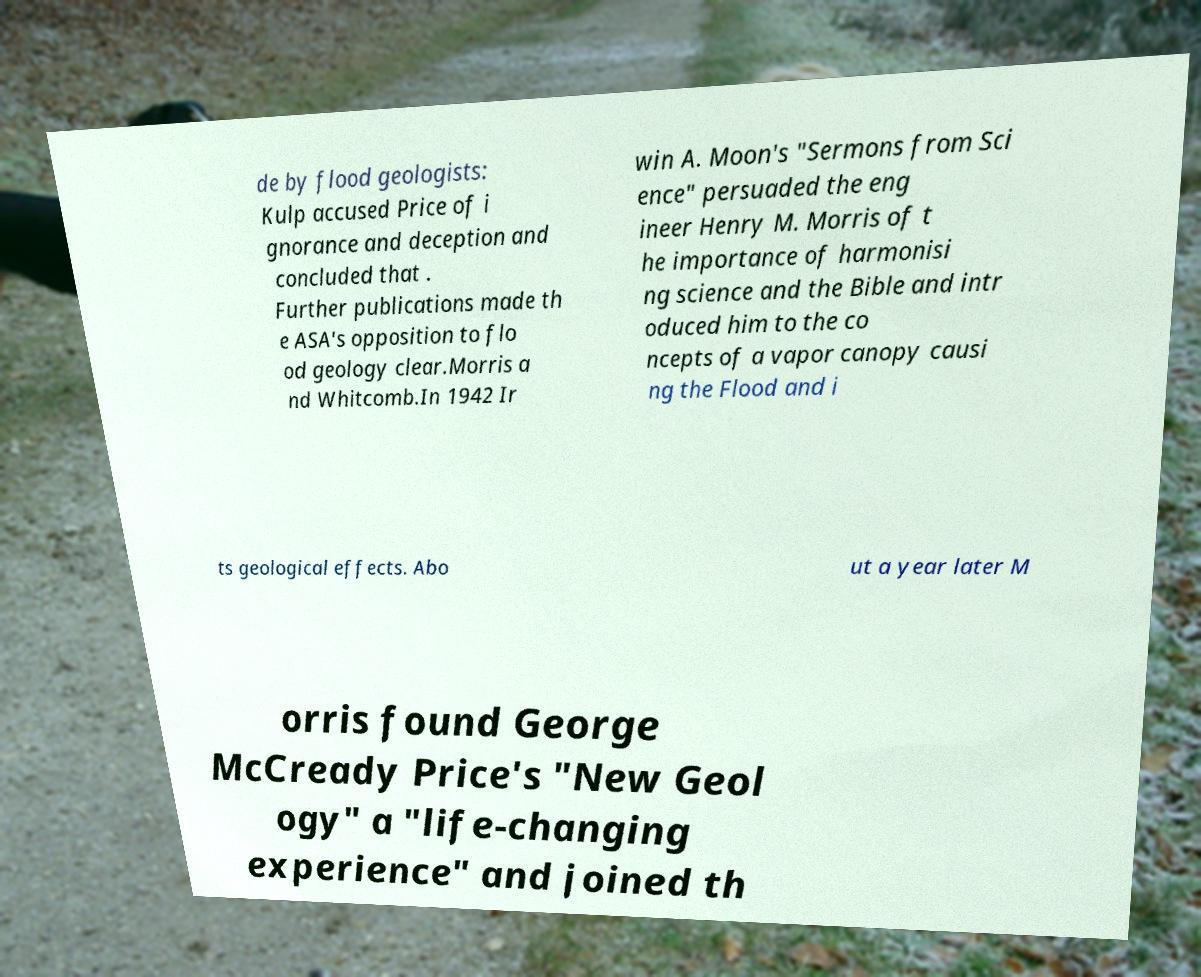There's text embedded in this image that I need extracted. Can you transcribe it verbatim? de by flood geologists: Kulp accused Price of i gnorance and deception and concluded that . Further publications made th e ASA's opposition to flo od geology clear.Morris a nd Whitcomb.In 1942 Ir win A. Moon's "Sermons from Sci ence" persuaded the eng ineer Henry M. Morris of t he importance of harmonisi ng science and the Bible and intr oduced him to the co ncepts of a vapor canopy causi ng the Flood and i ts geological effects. Abo ut a year later M orris found George McCready Price's "New Geol ogy" a "life-changing experience" and joined th 